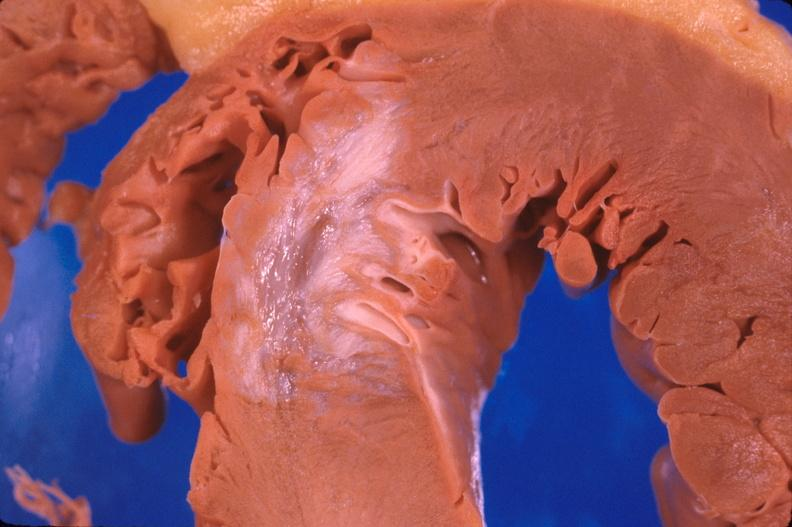what does this image show?
Answer the question using a single word or phrase. Heart 